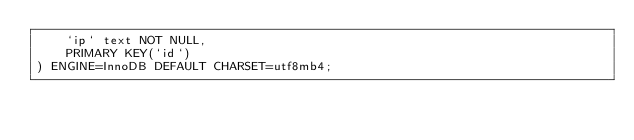<code> <loc_0><loc_0><loc_500><loc_500><_SQL_>    `ip` text NOT NULL,
    PRIMARY KEY(`id`)
) ENGINE=InnoDB DEFAULT CHARSET=utf8mb4;</code> 